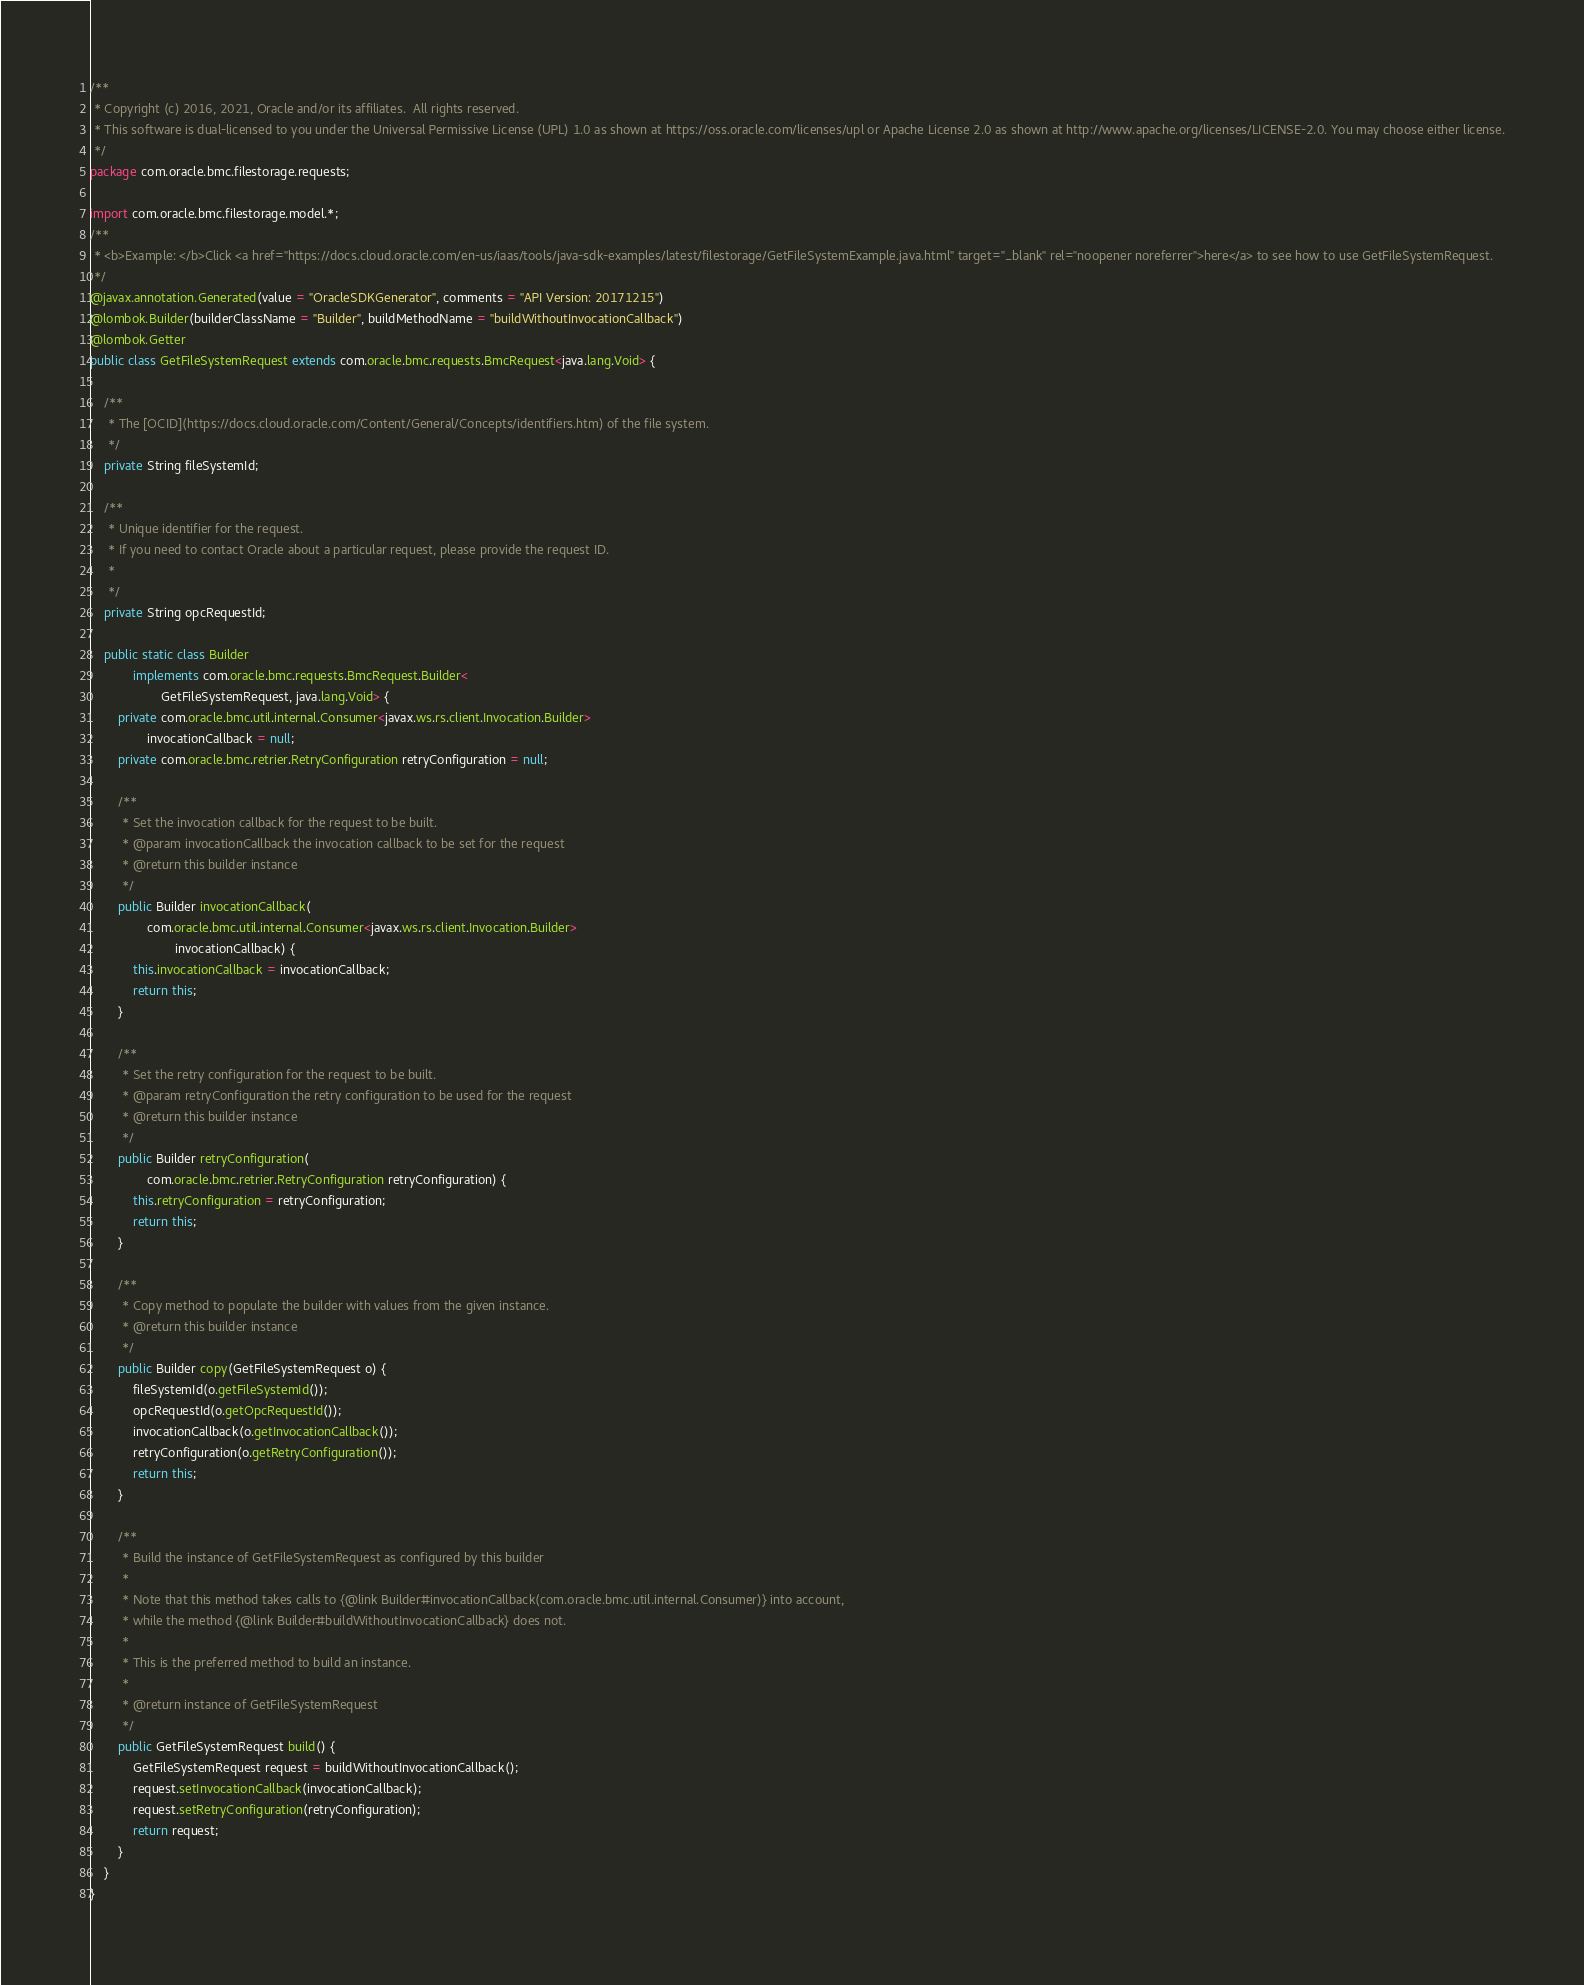Convert code to text. <code><loc_0><loc_0><loc_500><loc_500><_Java_>/**
 * Copyright (c) 2016, 2021, Oracle and/or its affiliates.  All rights reserved.
 * This software is dual-licensed to you under the Universal Permissive License (UPL) 1.0 as shown at https://oss.oracle.com/licenses/upl or Apache License 2.0 as shown at http://www.apache.org/licenses/LICENSE-2.0. You may choose either license.
 */
package com.oracle.bmc.filestorage.requests;

import com.oracle.bmc.filestorage.model.*;
/**
 * <b>Example: </b>Click <a href="https://docs.cloud.oracle.com/en-us/iaas/tools/java-sdk-examples/latest/filestorage/GetFileSystemExample.java.html" target="_blank" rel="noopener noreferrer">here</a> to see how to use GetFileSystemRequest.
 */
@javax.annotation.Generated(value = "OracleSDKGenerator", comments = "API Version: 20171215")
@lombok.Builder(builderClassName = "Builder", buildMethodName = "buildWithoutInvocationCallback")
@lombok.Getter
public class GetFileSystemRequest extends com.oracle.bmc.requests.BmcRequest<java.lang.Void> {

    /**
     * The [OCID](https://docs.cloud.oracle.com/Content/General/Concepts/identifiers.htm) of the file system.
     */
    private String fileSystemId;

    /**
     * Unique identifier for the request.
     * If you need to contact Oracle about a particular request, please provide the request ID.
     *
     */
    private String opcRequestId;

    public static class Builder
            implements com.oracle.bmc.requests.BmcRequest.Builder<
                    GetFileSystemRequest, java.lang.Void> {
        private com.oracle.bmc.util.internal.Consumer<javax.ws.rs.client.Invocation.Builder>
                invocationCallback = null;
        private com.oracle.bmc.retrier.RetryConfiguration retryConfiguration = null;

        /**
         * Set the invocation callback for the request to be built.
         * @param invocationCallback the invocation callback to be set for the request
         * @return this builder instance
         */
        public Builder invocationCallback(
                com.oracle.bmc.util.internal.Consumer<javax.ws.rs.client.Invocation.Builder>
                        invocationCallback) {
            this.invocationCallback = invocationCallback;
            return this;
        }

        /**
         * Set the retry configuration for the request to be built.
         * @param retryConfiguration the retry configuration to be used for the request
         * @return this builder instance
         */
        public Builder retryConfiguration(
                com.oracle.bmc.retrier.RetryConfiguration retryConfiguration) {
            this.retryConfiguration = retryConfiguration;
            return this;
        }

        /**
         * Copy method to populate the builder with values from the given instance.
         * @return this builder instance
         */
        public Builder copy(GetFileSystemRequest o) {
            fileSystemId(o.getFileSystemId());
            opcRequestId(o.getOpcRequestId());
            invocationCallback(o.getInvocationCallback());
            retryConfiguration(o.getRetryConfiguration());
            return this;
        }

        /**
         * Build the instance of GetFileSystemRequest as configured by this builder
         *
         * Note that this method takes calls to {@link Builder#invocationCallback(com.oracle.bmc.util.internal.Consumer)} into account,
         * while the method {@link Builder#buildWithoutInvocationCallback} does not.
         *
         * This is the preferred method to build an instance.
         *
         * @return instance of GetFileSystemRequest
         */
        public GetFileSystemRequest build() {
            GetFileSystemRequest request = buildWithoutInvocationCallback();
            request.setInvocationCallback(invocationCallback);
            request.setRetryConfiguration(retryConfiguration);
            return request;
        }
    }
}
</code> 